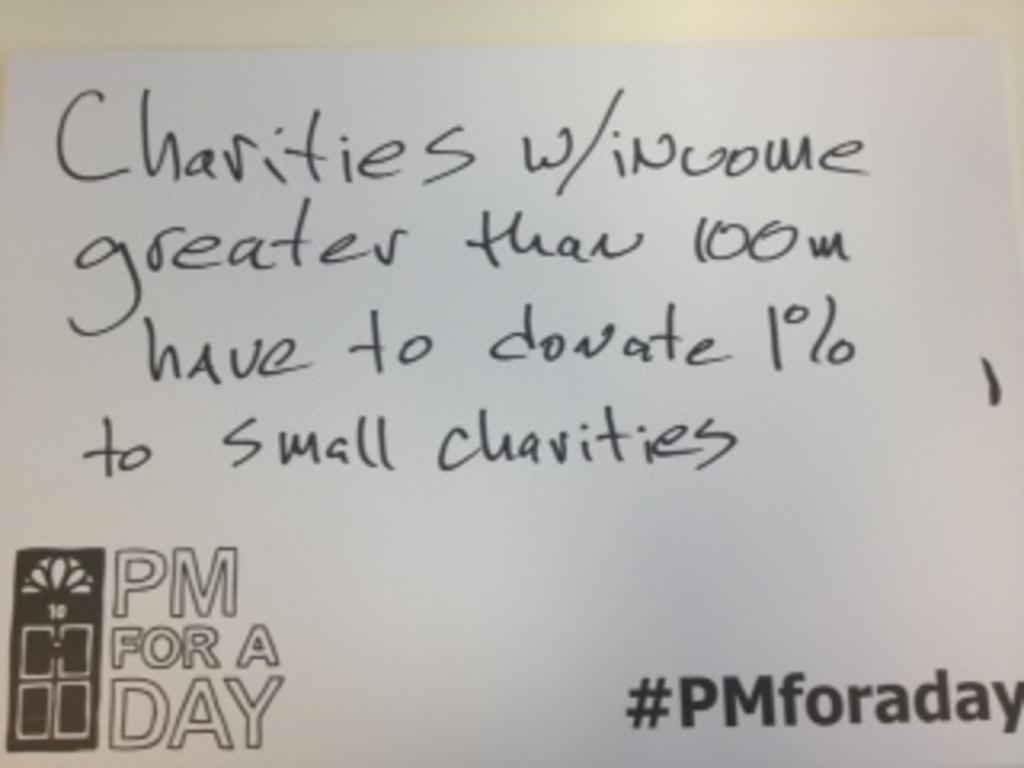How much to they have to donate?
Your answer should be compact. 1%. 